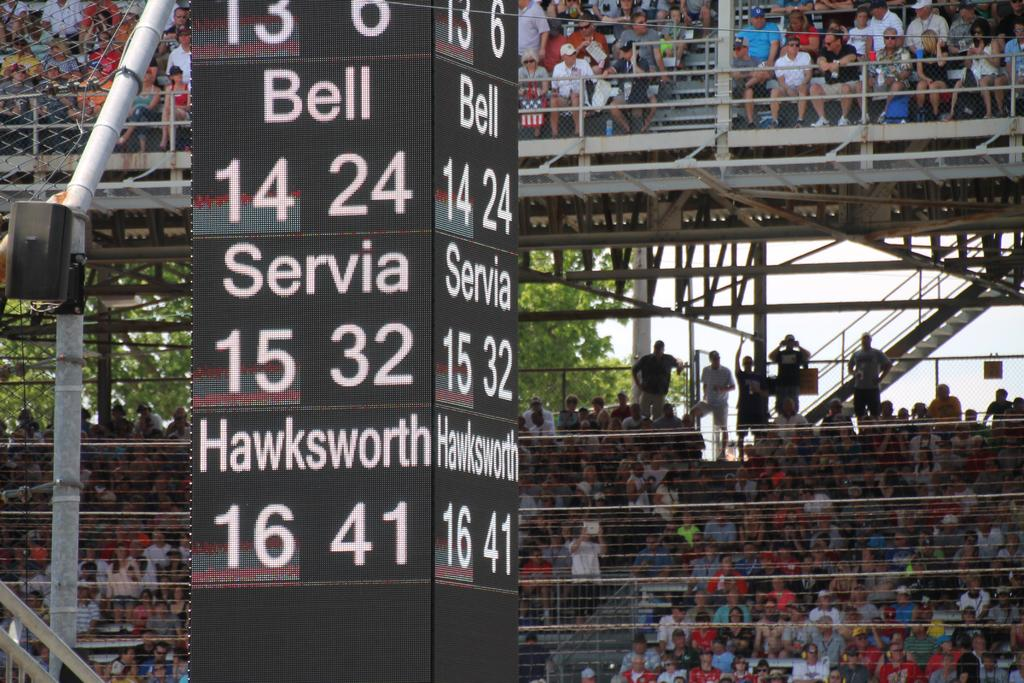<image>
Give a short and clear explanation of the subsequent image. a large black scoreboard with white writing including servia and hawksworth 